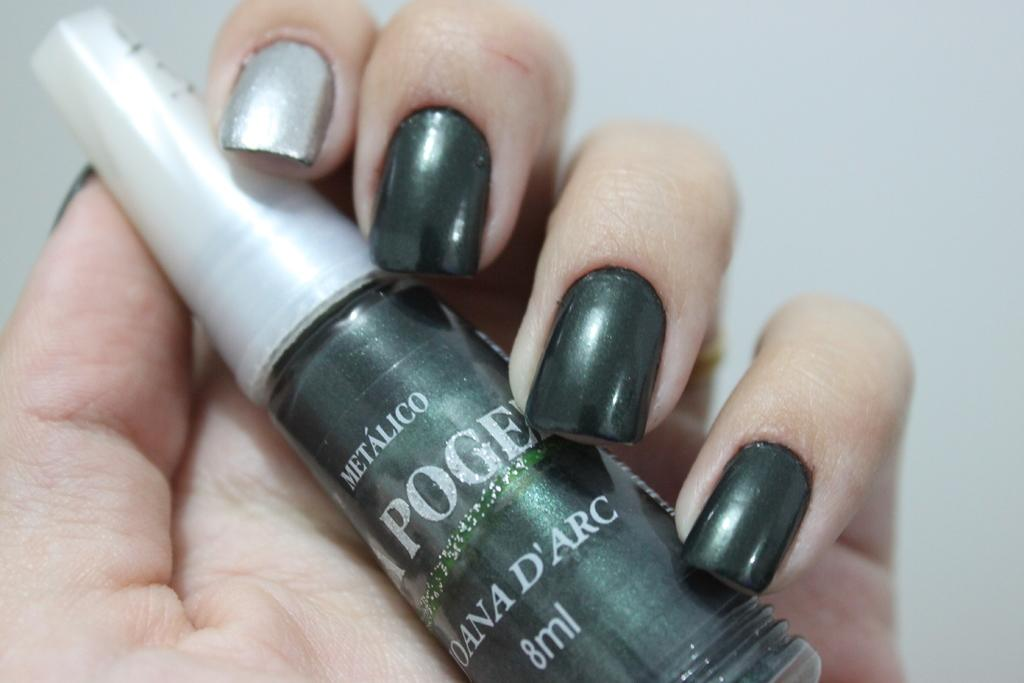Provide a one-sentence caption for the provided image. a persons nails are painted with Metalico nail polish. 